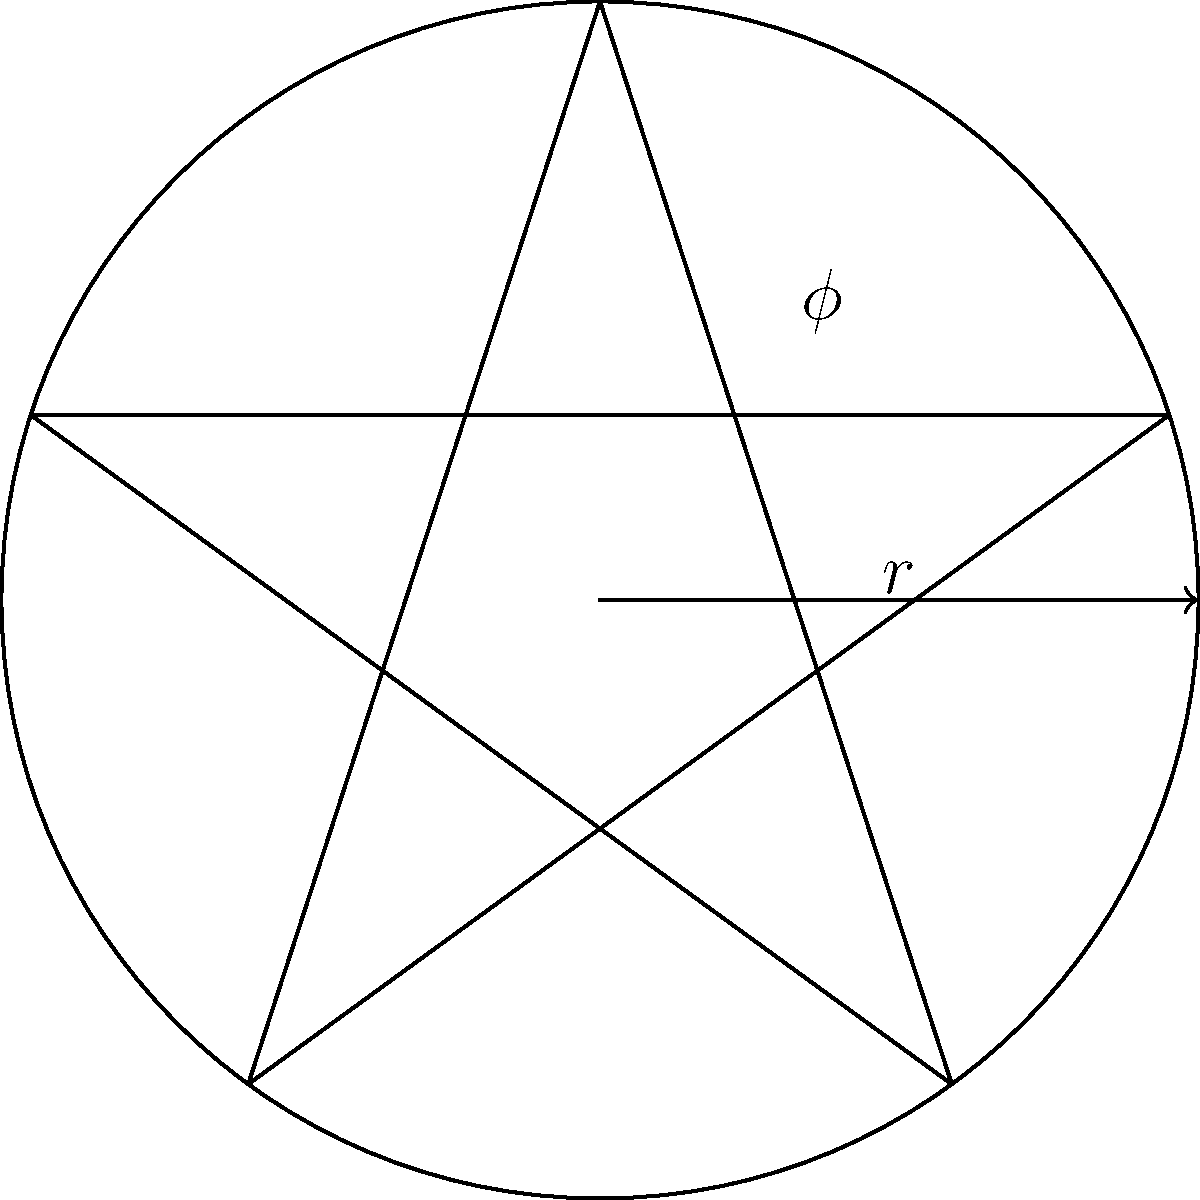In the pentagram inscribed within a circle, as shown in the diagram, what is the ratio of the length of the pentagram's side to the radius of the circle? Express your answer in terms of the golden ratio $\phi$. To solve this problem, we'll follow these steps:

1) The golden ratio $\phi$ is defined as $\phi = \frac{1+\sqrt{5}}{2} \approx 1.618$.

2) In a regular pentagram, the ratio of a diagonal to a side is equal to $\phi$.

3) The pentagram inscribed in a circle forms 10 triangles. The ratio of the long side (diagonal) to the short side in these triangles is $\phi$.

4) The radius of the circle is the long side of these triangles, while the side of the pentagram is the short side.

5) Therefore, if we denote the radius as $r$ and the side of the pentagram as $s$, we have:

   $\frac{r}{s} = \phi$

6) To express $s$ in terms of $r$ and $\phi$, we rearrange this equation:

   $s = \frac{r}{\phi}$

7) The question asks for the ratio of $s$ to $r$, which is:

   $\frac{s}{r} = \frac{r/\phi}{r} = \frac{1}{\phi}$

Thus, the ratio of the pentagram's side to the circle's radius is $\frac{1}{\phi}$.
Answer: $\frac{1}{\phi}$ 